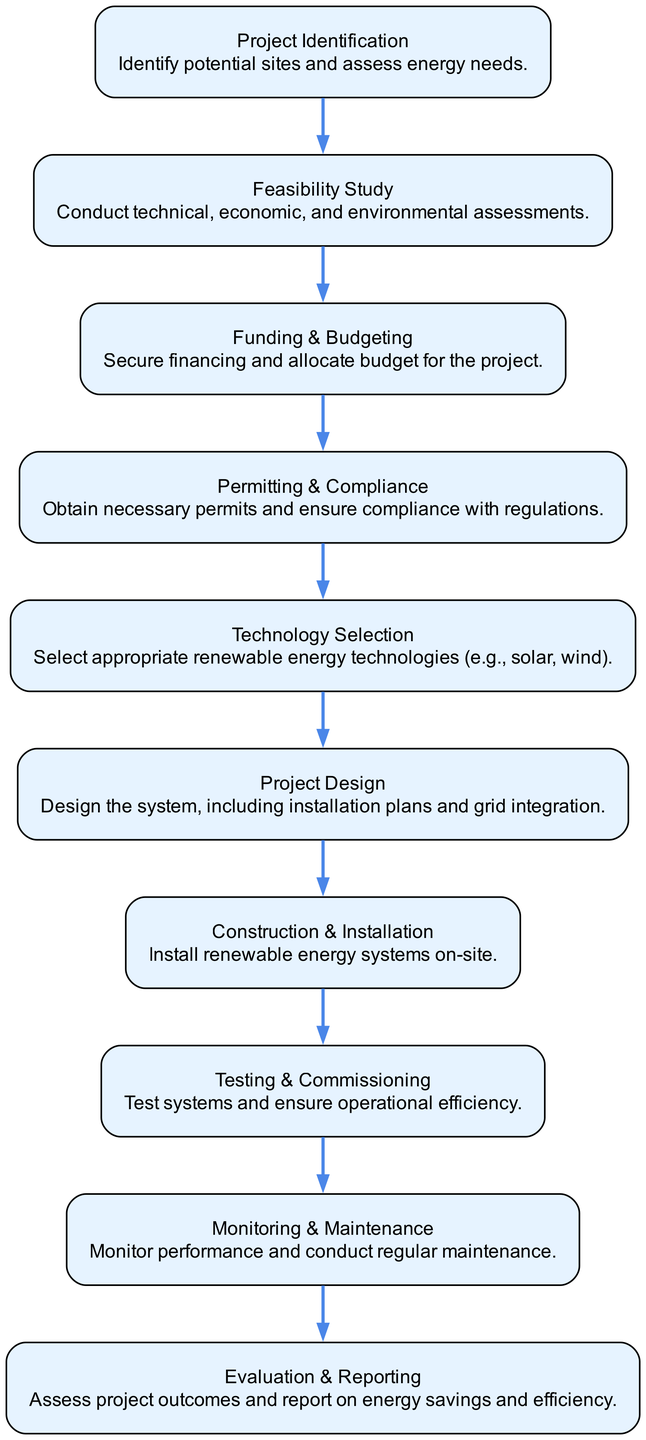What's the first step in the process? The diagram starts with "Project Identification," indicating that this is the initial phase where potential sites are identified and energy needs are assessed.
Answer: Project Identification How many steps are there in the process? By counting the nodes in the flow chart, I found ten distinct steps, which encompass all the crucial stages of the renewable energy project implementation.
Answer: Ten Which step follows the "Technology Selection"? The next step after "Technology Selection" is "Project Design," showing that after selecting the technologies, the design phase begins to outline the system.
Answer: Project Design What type of assessments are done in the "Feasibility Study"? The "Feasibility Study" involves conducting technical, economic, and environmental assessments, as noted in the description of this step.
Answer: Technical, economic, and environmental assessments What is the last step in the renewable energy project implementation process? The final stage as depicted in the flow chart is "Evaluation & Reporting," where the project's outcomes are assessed and reported on.
Answer: Evaluation & Reporting Which steps involve compliance and regulation? The "Permitting & Compliance" step specifically mentions obtaining necessary permits and ensuring compliance with regulations, thus focusing on legal and regulatory aspects.
Answer: Permitting & Compliance What is the primary focus of the "Monitoring & Maintenance" step? The focus of "Monitoring & Maintenance" is on tracking system performance and conducting regular maintenance to ensure continual operational efficiency.
Answer: Performance monitoring and maintenance Identify the step immediately preceding the "Construction & Installation." The step right before "Construction & Installation" is "Project Design," which involves planning the installation and grid integration before commencing construction.
Answer: Project Design 